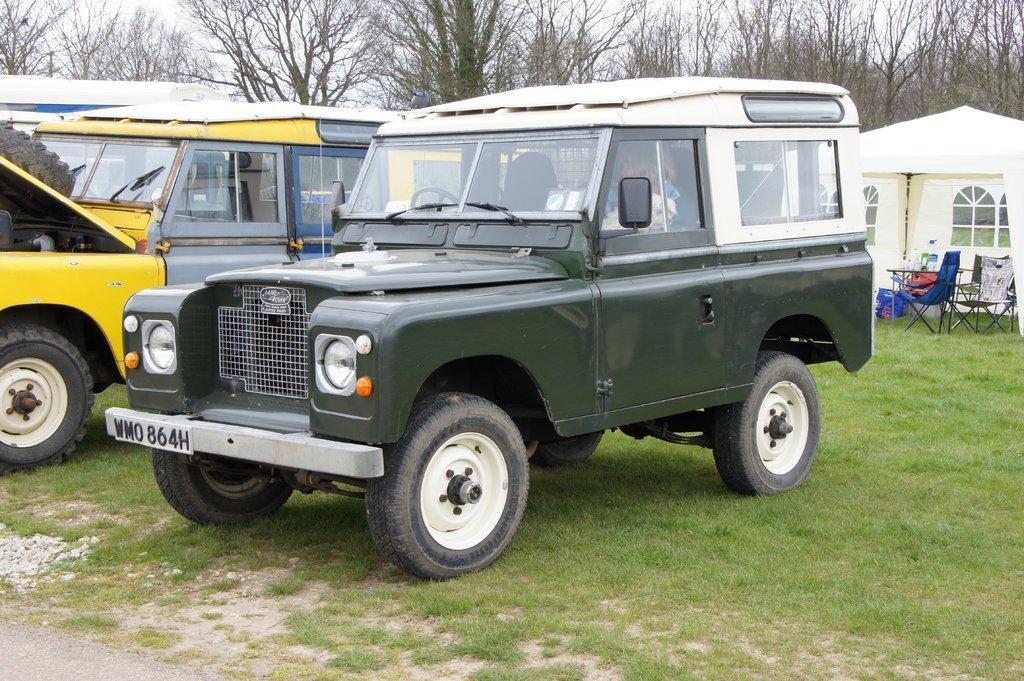Could you give a brief overview of what you see in this image? In this image there are two jeeps parked on the surface of the grass, behind the Jeep there are chairs and a table and a tent, behind the tent there are trees. 